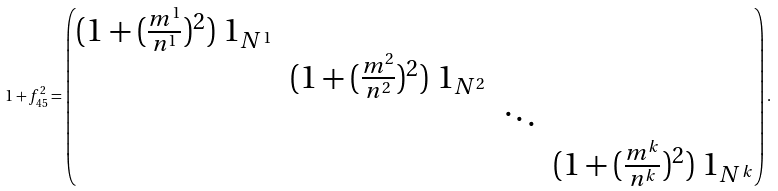<formula> <loc_0><loc_0><loc_500><loc_500>\ 1 + f _ { 4 5 } ^ { 2 } = \begin{pmatrix} ( 1 + ( \frac { m ^ { 1 } } { n ^ { 1 } } ) ^ { 2 } ) \ 1 _ { N ^ { 1 } } & & & \\ & ( 1 + ( \frac { m ^ { 2 } } { n ^ { 2 } } ) ^ { 2 } ) \ 1 _ { N ^ { 2 } } & & \\ & & \ddots & \\ & & & ( 1 + ( \frac { m ^ { k } } { n ^ { k } } ) ^ { 2 } ) \ 1 _ { N ^ { k } } \end{pmatrix} .</formula> 